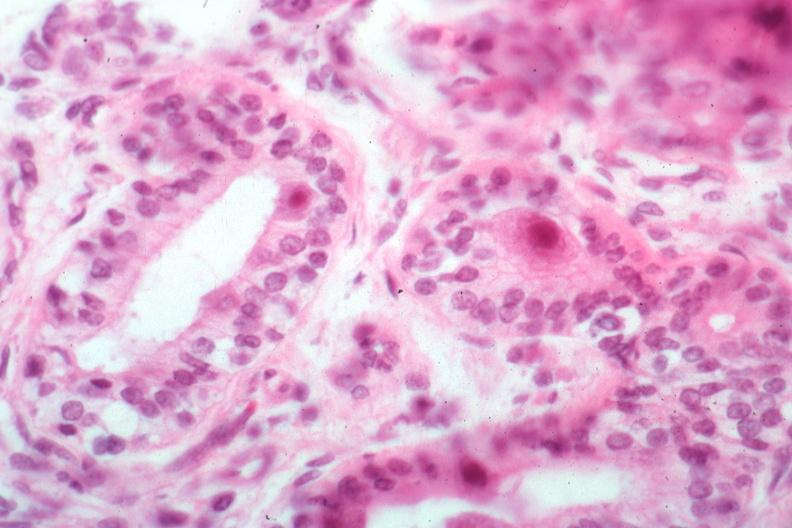s submaxillary gland present?
Answer the question using a single word or phrase. Yes 